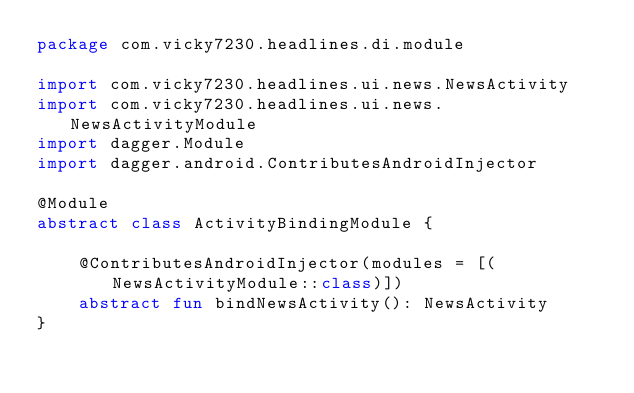Convert code to text. <code><loc_0><loc_0><loc_500><loc_500><_Kotlin_>package com.vicky7230.headlines.di.module

import com.vicky7230.headlines.ui.news.NewsActivity
import com.vicky7230.headlines.ui.news.NewsActivityModule
import dagger.Module
import dagger.android.ContributesAndroidInjector

@Module
abstract class ActivityBindingModule {

    @ContributesAndroidInjector(modules = [(NewsActivityModule::class)])
    abstract fun bindNewsActivity(): NewsActivity
}</code> 